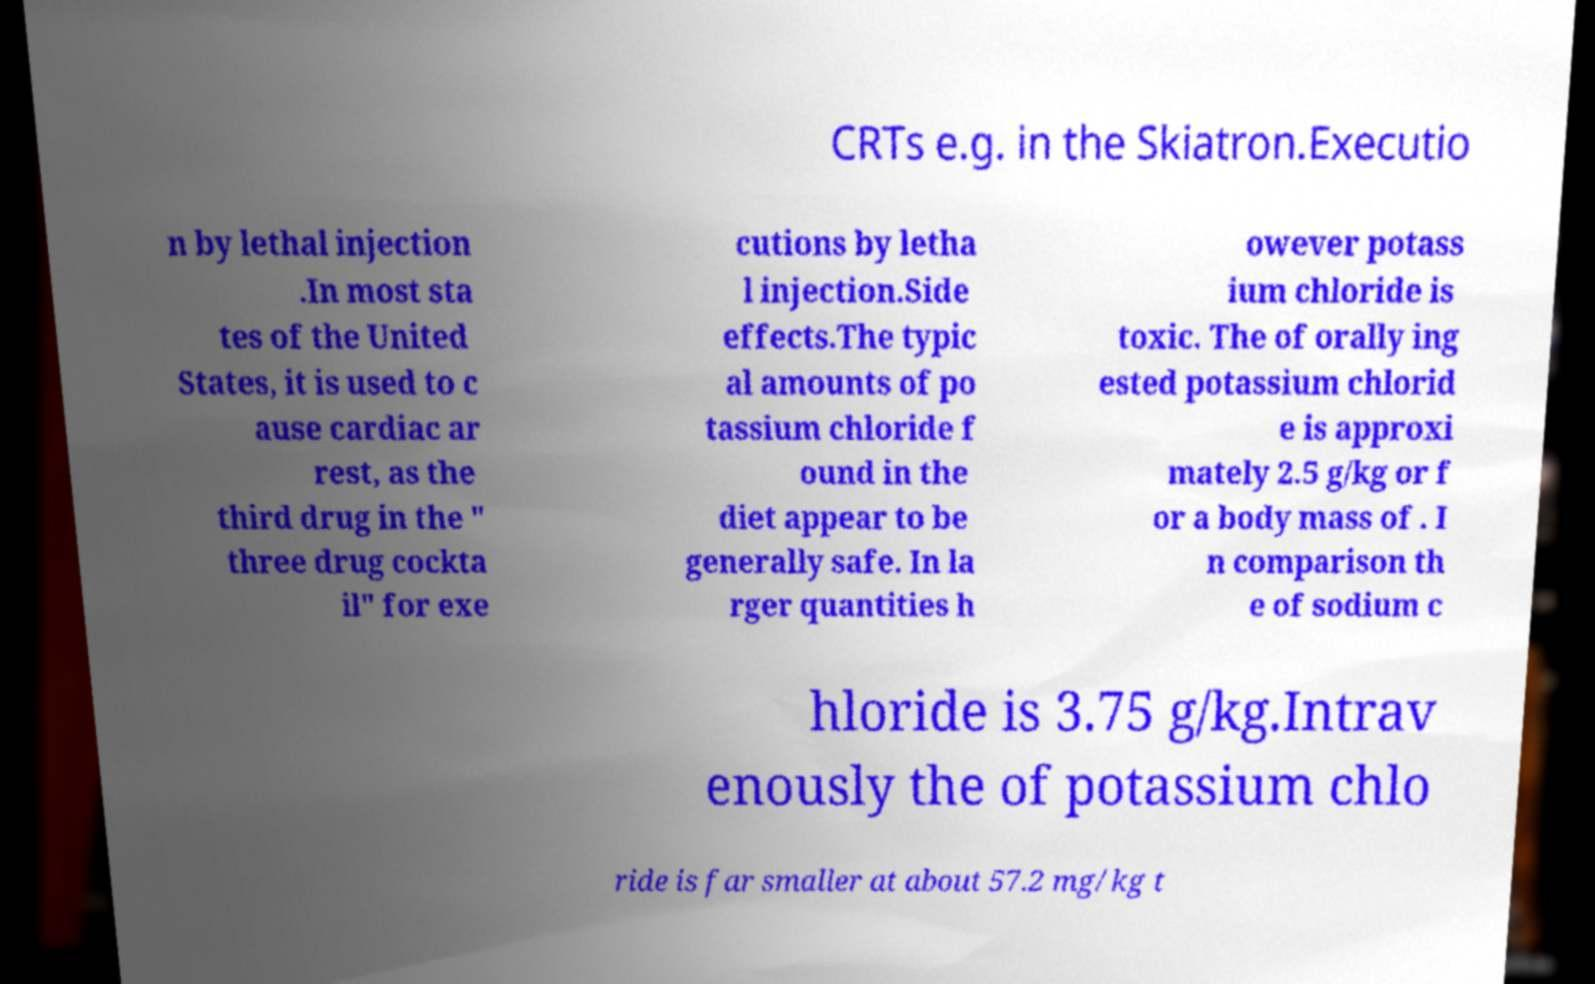What messages or text are displayed in this image? I need them in a readable, typed format. CRTs e.g. in the Skiatron.Executio n by lethal injection .In most sta tes of the United States, it is used to c ause cardiac ar rest, as the third drug in the " three drug cockta il" for exe cutions by letha l injection.Side effects.The typic al amounts of po tassium chloride f ound in the diet appear to be generally safe. In la rger quantities h owever potass ium chloride is toxic. The of orally ing ested potassium chlorid e is approxi mately 2.5 g/kg or f or a body mass of . I n comparison th e of sodium c hloride is 3.75 g/kg.Intrav enously the of potassium chlo ride is far smaller at about 57.2 mg/kg t 